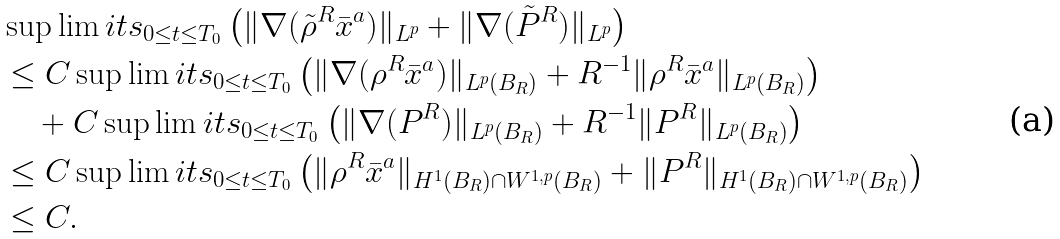<formula> <loc_0><loc_0><loc_500><loc_500>& \sup \lim i t s _ { 0 \leq t \leq T _ { 0 } } \left ( \| \nabla ( \tilde { \rho } ^ { R } \bar { x } ^ { a } ) \| _ { L ^ { p } } + \| \nabla ( \tilde { P } ^ { R } ) \| _ { L ^ { p } } \right ) \\ & \leq C \sup \lim i t s _ { 0 \leq t \leq T _ { 0 } } \left ( \| \nabla ( \rho ^ { R } \bar { x } ^ { a } ) \| _ { L ^ { p } ( B _ { R } ) } + R ^ { - 1 } \| \rho ^ { R } \bar { x } ^ { a } \| _ { L ^ { p } ( B _ { R } ) } \right ) \\ & \quad + C \sup \lim i t s _ { 0 \leq t \leq T _ { 0 } } \left ( \| \nabla ( P ^ { R } ) \| _ { L ^ { p } ( B _ { R } ) } + R ^ { - 1 } \| P ^ { R } \| _ { L ^ { p } ( B _ { R } ) } \right ) \\ & \leq C \sup \lim i t s _ { 0 \leq t \leq T _ { 0 } } \left ( \| \rho ^ { R } \bar { x } ^ { a } \| _ { H ^ { 1 } ( B _ { R } ) \cap W ^ { 1 , p } ( B _ { R } ) } + \| P ^ { R } \| _ { H ^ { 1 } ( B _ { R } ) \cap W ^ { 1 , p } ( B _ { R } ) } \right ) \\ & \leq C .</formula> 